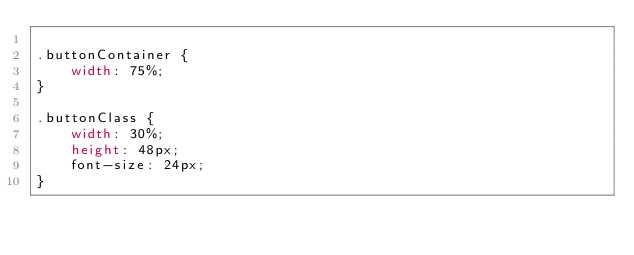Convert code to text. <code><loc_0><loc_0><loc_500><loc_500><_CSS_>  
.buttonContainer {
    width: 75%;
}
            
.buttonClass {
    width: 30%;
    height: 48px;
    font-size: 24px;
}</code> 